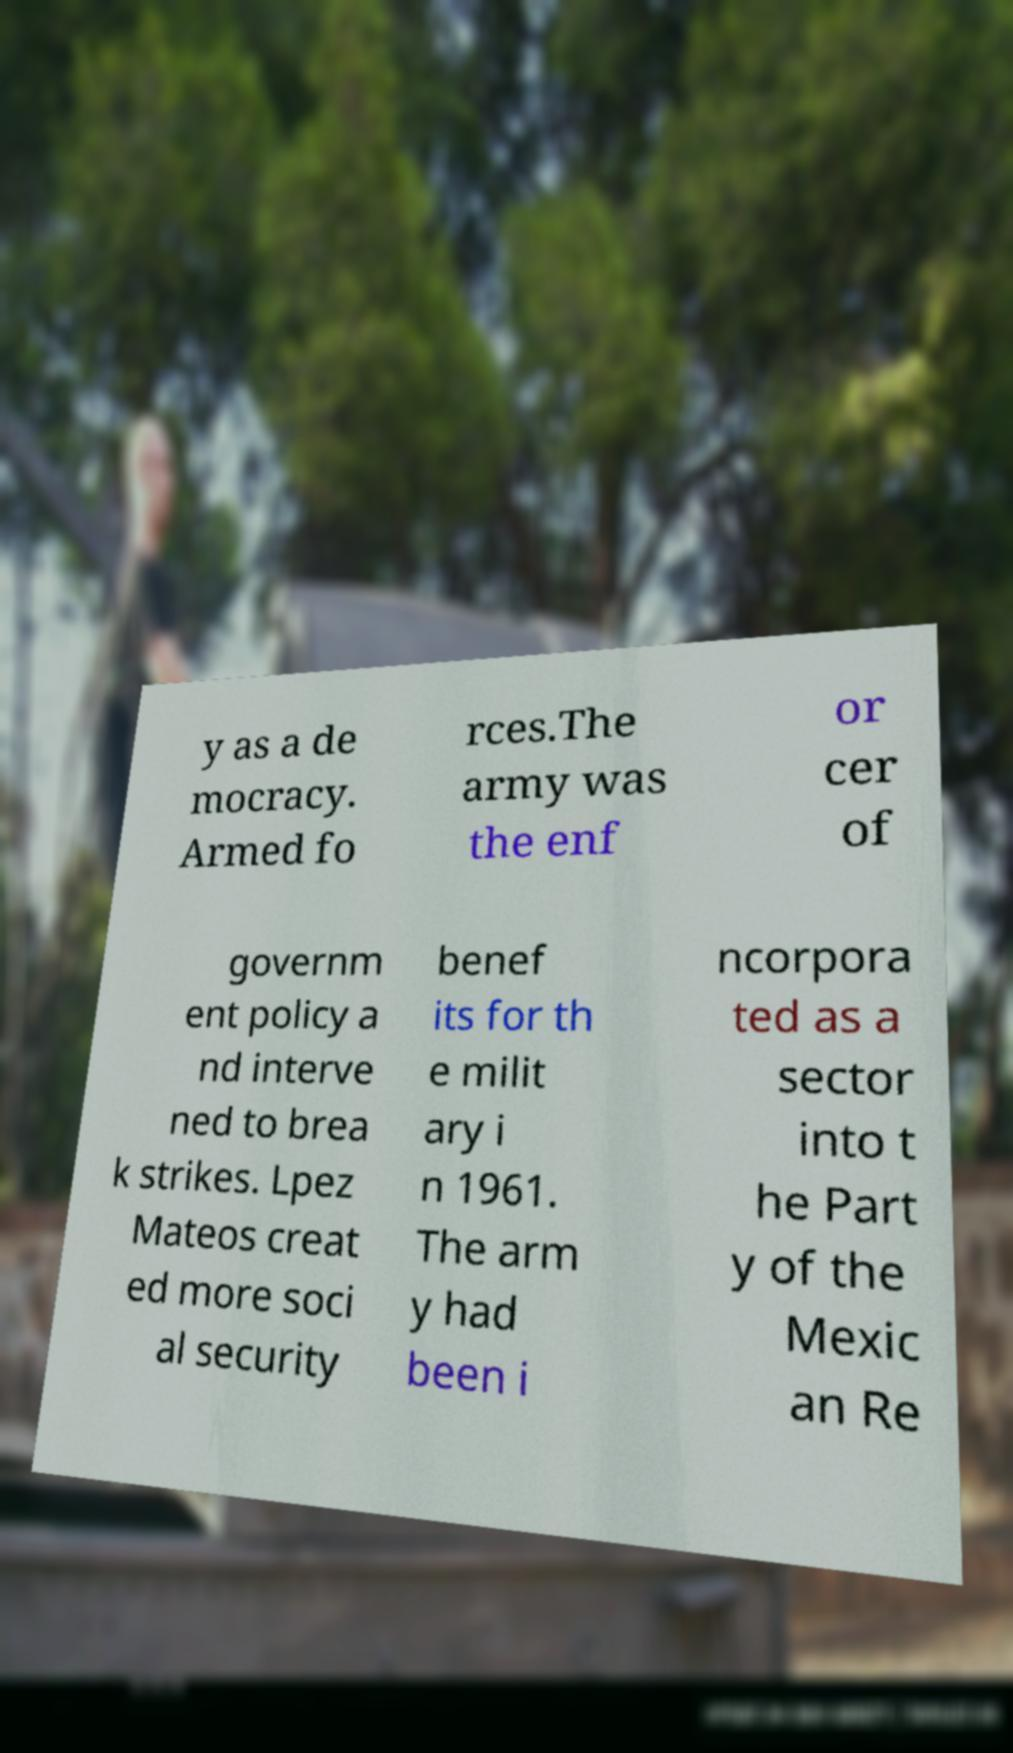Could you assist in decoding the text presented in this image and type it out clearly? y as a de mocracy. Armed fo rces.The army was the enf or cer of governm ent policy a nd interve ned to brea k strikes. Lpez Mateos creat ed more soci al security benef its for th e milit ary i n 1961. The arm y had been i ncorpora ted as a sector into t he Part y of the Mexic an Re 